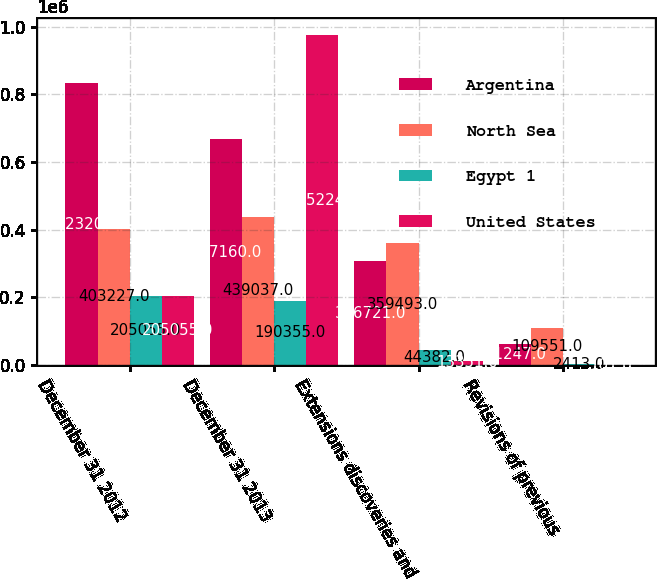<chart> <loc_0><loc_0><loc_500><loc_500><stacked_bar_chart><ecel><fcel>December 31 2012<fcel>December 31 2013<fcel>Extensions discoveries and<fcel>Revisions of previous<nl><fcel>Argentina<fcel>832320<fcel>667160<fcel>306721<fcel>61247<nl><fcel>North Sea<fcel>403227<fcel>439037<fcel>359493<fcel>109551<nl><fcel>Egypt 1<fcel>205055<fcel>190355<fcel>44382<fcel>2413<nl><fcel>United States<fcel>205055<fcel>975224<fcel>13351<fcel>101<nl></chart> 